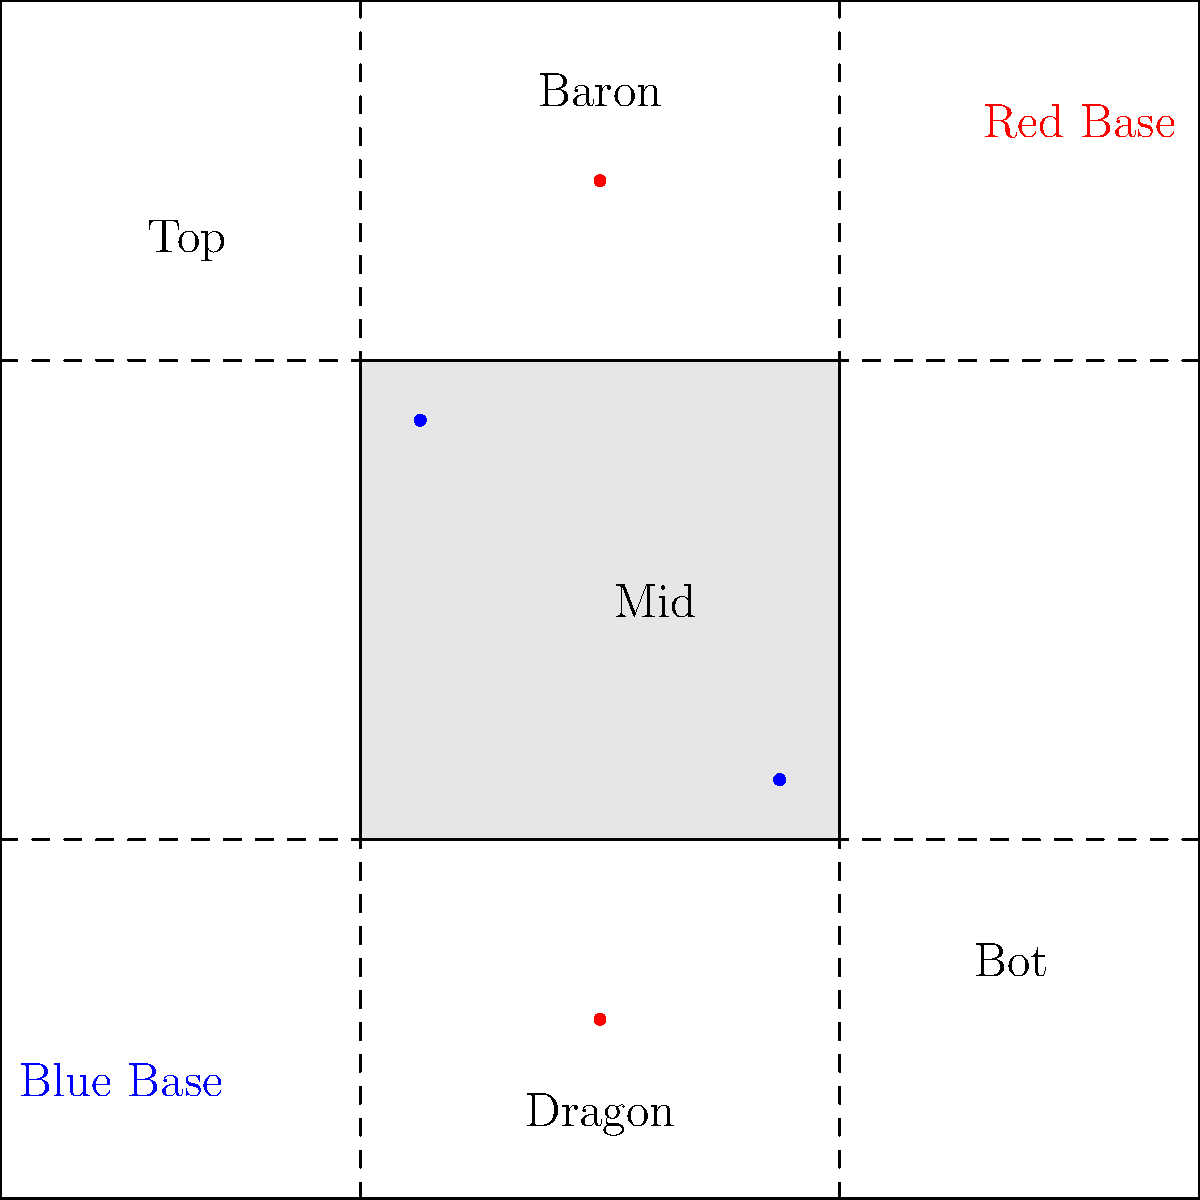In Summoner's Rift, which objective is located closer to the Red team's base, and how does this positioning affect the game dynamics? To answer this question, let's analyze the map layout of Summoner's Rift:

1. The map is divided into two halves, with the Blue team's base in the bottom-left corner and the Red team's base in the top-right corner.

2. There are two major neutral objectives on the map:
   a) Baron Nashor: Located in the top-center of the map
   b) Dragon: Located in the bottom-center of the map

3. Comparing the positions:
   - Baron Nashor is closer to the Red team's base
   - Dragon is closer to the Blue team's base

4. This positioning affects game dynamics in several ways:
   a) The Red team has easier access to Baron, which is typically considered the more important late-game objective.
   b) The Blue team has an advantage in securing early Dragons, which can provide cumulative bonuses throughout the game.
   c) The Red team may need to invest more resources in warding and controlling the Dragon area.
   d) The Blue team may need to be more proactive in contesting and setting up vision around Baron.

5. Teams often adjust their strategies based on this layout:
   - Red team might prioritize top-side control to leverage their Baron advantage.
   - Blue team might focus more on bot-side control to secure Dragons more easily.

In competitive play, understanding and exploiting these positional advantages can significantly impact the outcome of the game.
Answer: Baron Nashor; influences objective control strategies 